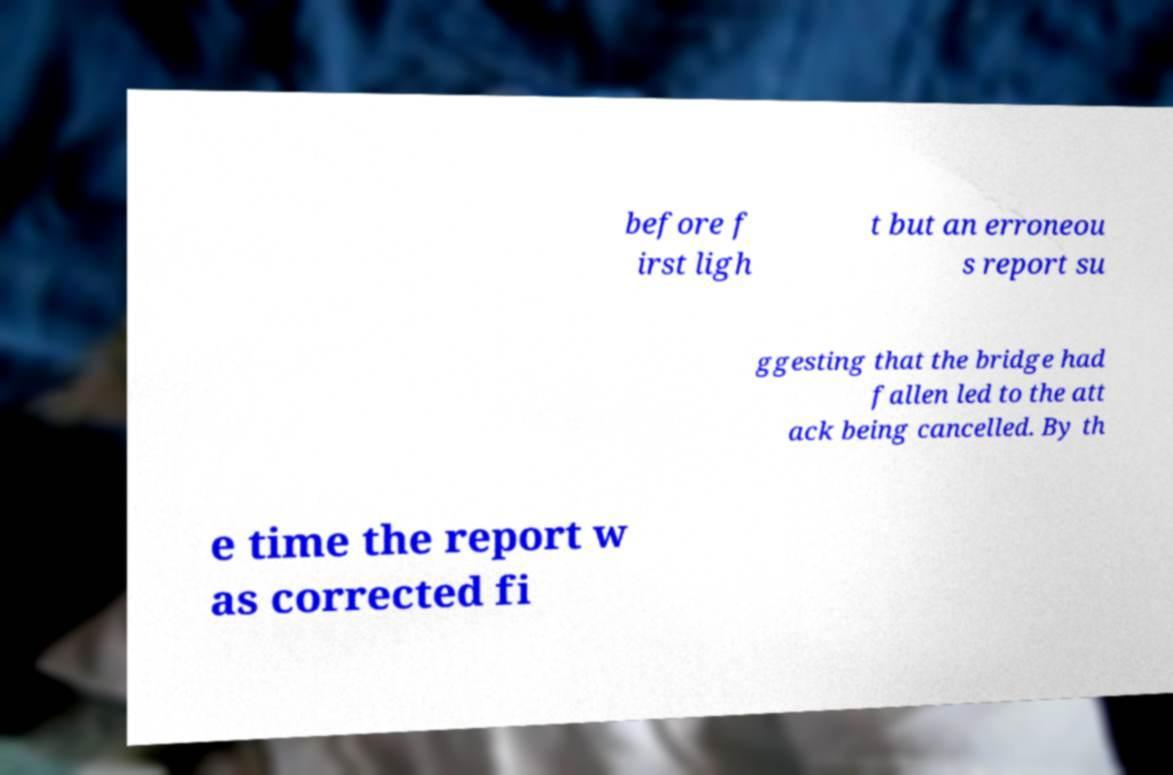There's text embedded in this image that I need extracted. Can you transcribe it verbatim? before f irst ligh t but an erroneou s report su ggesting that the bridge had fallen led to the att ack being cancelled. By th e time the report w as corrected fi 